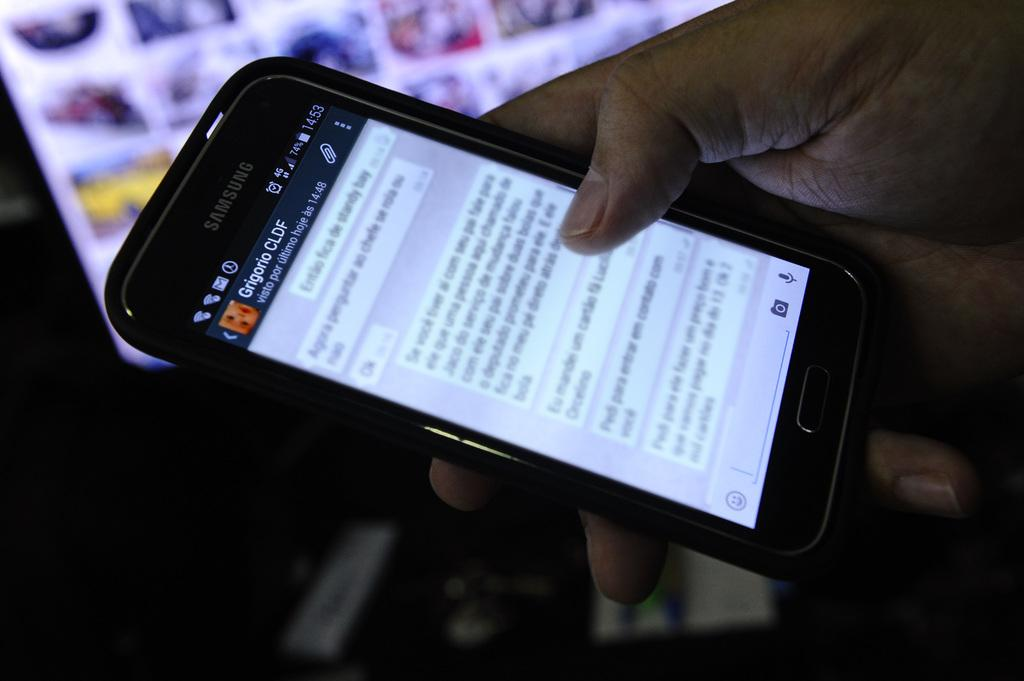<image>
Provide a brief description of the given image. a phone that has CLDF written on it 